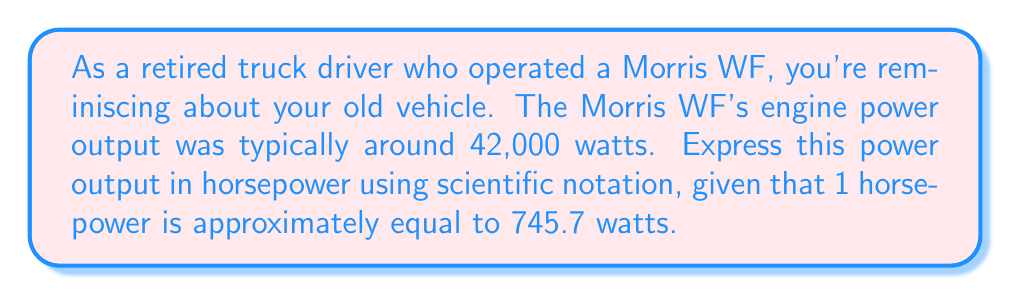Solve this math problem. To solve this problem, we'll follow these steps:

1) First, we need to convert watts to horsepower:
   $$ \text{Horsepower} = \frac{\text{Watts}}{\text{Watts per Horsepower}} $$

2) Let's substitute the values:
   $$ \text{Horsepower} = \frac{42,000}{745.7} $$

3) Perform the division:
   $$ \text{Horsepower} \approx 56.3242 $$

4) Now, we need to express this in scientific notation. In scientific notation, a number is expressed as $a \times 10^n$, where $1 \leq |a| < 10$ and $n$ is an integer.

5) In this case:
   $$ 56.3242 = 5.63242 \times 10^1 $$

6) Rounding to 2 decimal places for a more manageable result:
   $$ 56.32 = 5.63 \times 10^1 \text{ horsepower} $$
Answer: $5.63 \times 10^1$ horsepower 